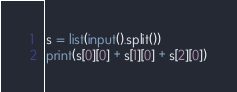<code> <loc_0><loc_0><loc_500><loc_500><_Python_>s = list(input().split())
print(s[0][0] + s[1][0] + s[2][0])
</code> 